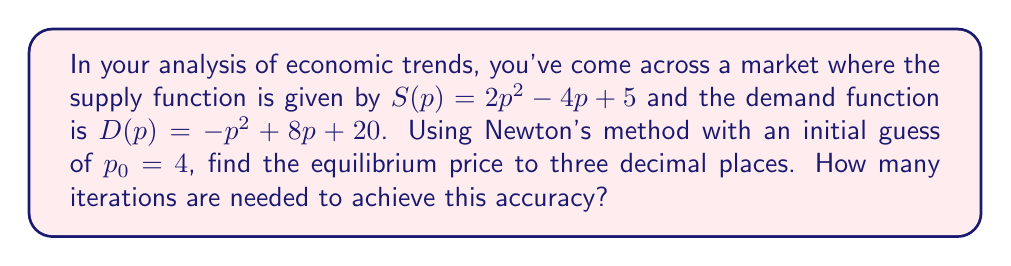Can you answer this question? To find the equilibrium price, we need to solve the equation $S(p) = D(p)$:

$$2p^2 - 4p + 5 = -p^2 + 8p + 20$$

Rearranging:

$$3p^2 - 12p - 15 = 0$$

Let $f(p) = 3p^2 - 12p - 15$

Newton's method is given by:

$$p_{n+1} = p_n - \frac{f(p_n)}{f'(p_n)}$$

Where $f'(p) = 6p - 12$

Starting with $p_0 = 4$:

Iteration 1:
$$p_1 = 4 - \frac{3(4)^2 - 12(4) - 15}{6(4) - 12} = 4 - \frac{33}{12} = 1.25$$

Iteration 2:
$$p_2 = 1.25 - \frac{3(1.25)^2 - 12(1.25) - 15}{6(1.25) - 12} \approx 5.0833$$

Iteration 3:
$$p_3 = 5.0833 - \frac{3(5.0833)^2 - 12(5.0833) - 15}{6(5.0833) - 12} \approx 5.0000$$

Iteration 4:
$$p_4 = 5.0000 - \frac{3(5.0000)^2 - 12(5.0000) - 15}{6(5.0000) - 12} \approx 5.0000$$

The value converges to 5.000 after 4 iterations, which is accurate to three decimal places.
Answer: Equilibrium price: $5.000$; 4 iterations needed 